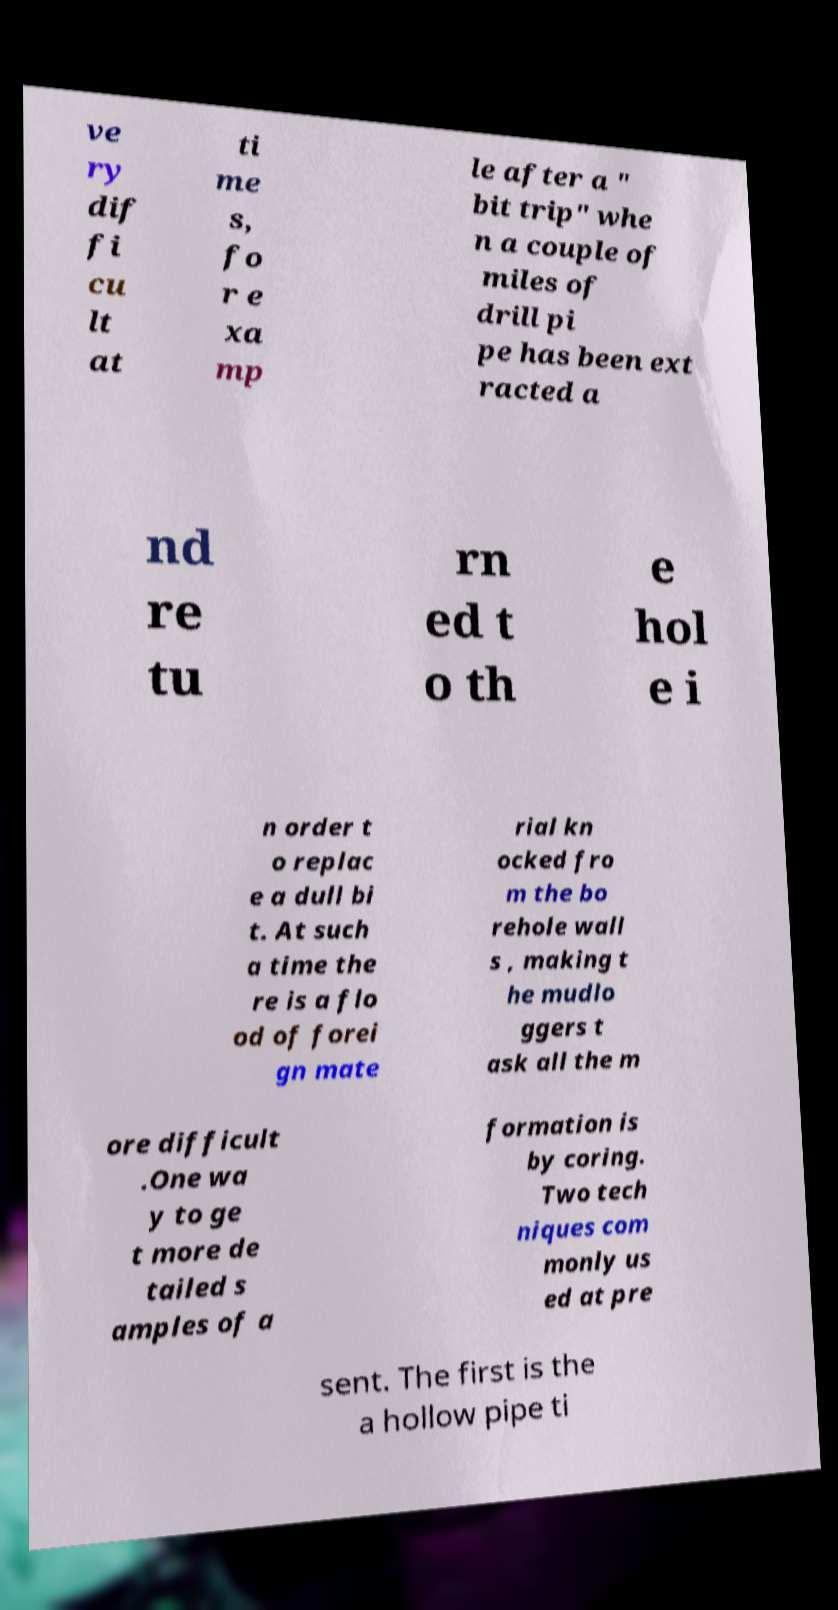Could you extract and type out the text from this image? ve ry dif fi cu lt at ti me s, fo r e xa mp le after a " bit trip" whe n a couple of miles of drill pi pe has been ext racted a nd re tu rn ed t o th e hol e i n order t o replac e a dull bi t. At such a time the re is a flo od of forei gn mate rial kn ocked fro m the bo rehole wall s , making t he mudlo ggers t ask all the m ore difficult .One wa y to ge t more de tailed s amples of a formation is by coring. Two tech niques com monly us ed at pre sent. The first is the a hollow pipe ti 